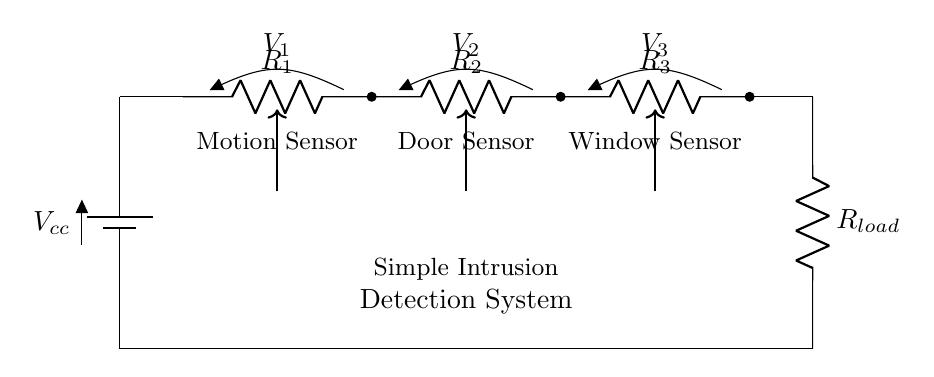What is the total resistance in this circuit? The total resistance in a series circuit is the sum of the individual resistances. In this circuit, it is R1 + R2 + R3 + Rload. If R1, R2, and R3 are each 1 ohm and Rload is also 1 ohm, the total resistance would be 1 + 1 + 1 + 1 = 4 ohms.
Answer: 4 ohms What are the sensors used in this circuit? The circuit diagram labels three sensors: a motion sensor, a door sensor, and a window sensor. Each sensor is connected in series to the rest of the circuit.
Answer: Motion sensor, door sensor, window sensor What role does the battery play in this circuit? The battery provides the voltage necessary for the circuit to function, supplying energy to power the sensors and the load. It is positioned at the top of the circuit diagram, indicating its role as the power source.
Answer: Power source What happens if one sensor fails? In a series circuit, if one component fails (for example, one sensor), it will break the circuit, and no current will flow. This means that all sensors will not function, leading to a complete system failure.
Answer: Complete failure If the voltage of the battery is greater, what is the expected effect on the load? Increasing the voltage from the battery would increase the current flowing through the circuit (according to Ohm's Law) and consequently increase the voltage across the load as well, assuming the resistances remain unchanged.
Answer: Increased load voltage 